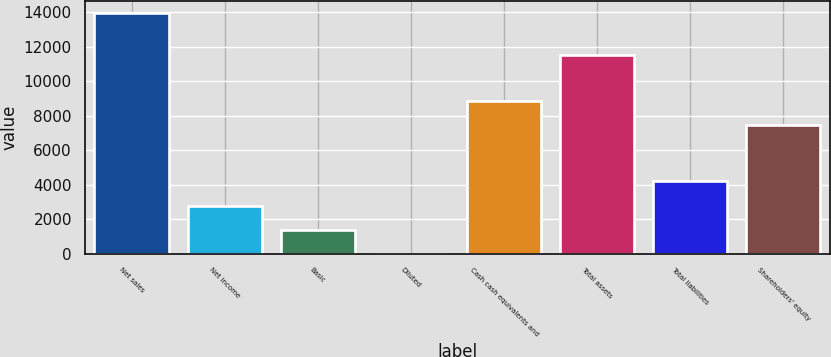<chart> <loc_0><loc_0><loc_500><loc_500><bar_chart><fcel>Net sales<fcel>Net income<fcel>Basic<fcel>Diluted<fcel>Cash cash equivalents and<fcel>Total assets<fcel>Total liabilities<fcel>Shareholders' equity<nl><fcel>13931<fcel>2787.45<fcel>1394.5<fcel>1.55<fcel>8820.94<fcel>11516<fcel>4180.4<fcel>7428<nl></chart> 